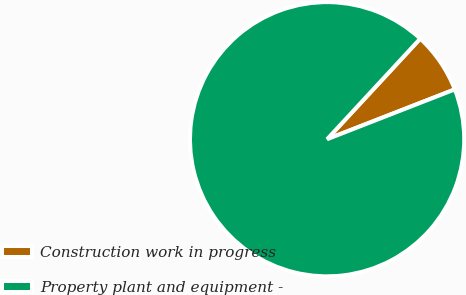Convert chart to OTSL. <chart><loc_0><loc_0><loc_500><loc_500><pie_chart><fcel>Construction work in progress<fcel>Property plant and equipment -<nl><fcel>7.19%<fcel>92.81%<nl></chart> 